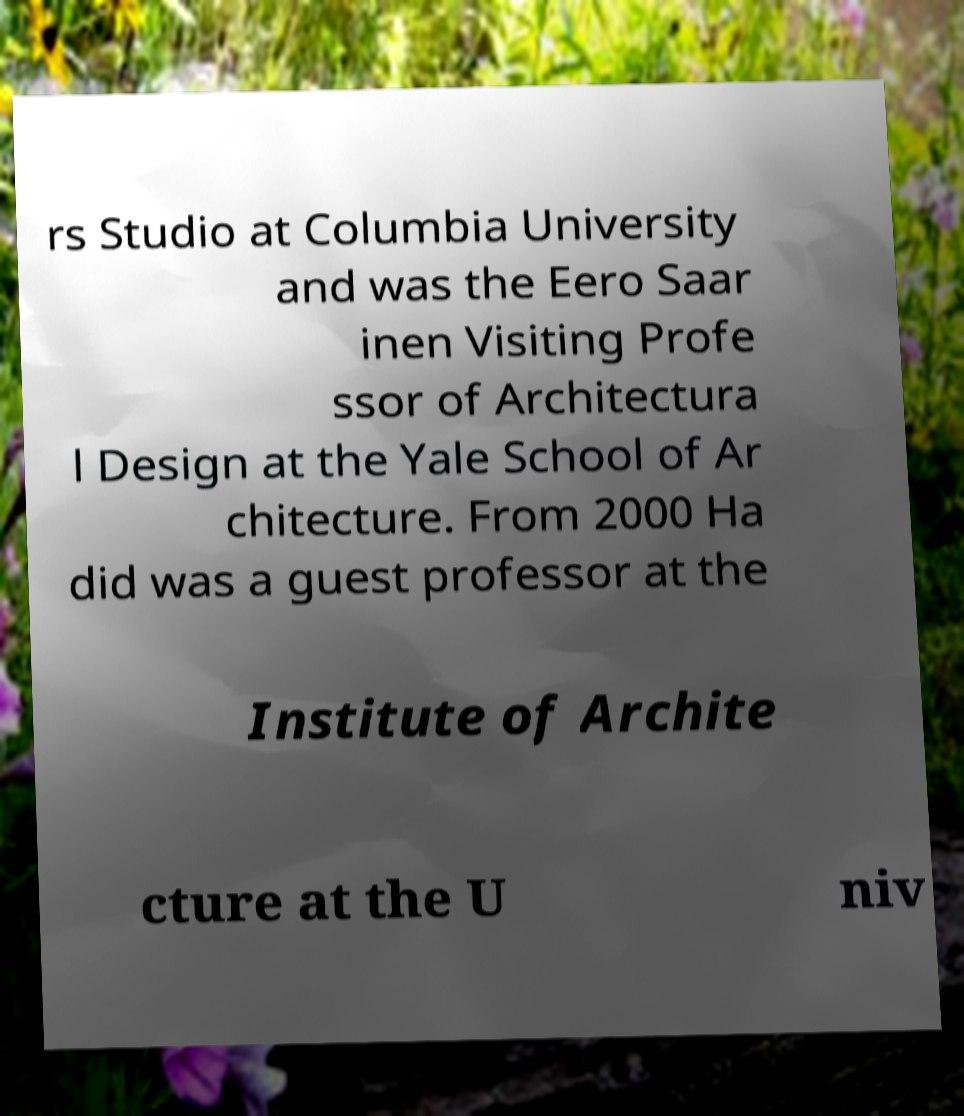Can you read and provide the text displayed in the image?This photo seems to have some interesting text. Can you extract and type it out for me? rs Studio at Columbia University and was the Eero Saar inen Visiting Profe ssor of Architectura l Design at the Yale School of Ar chitecture. From 2000 Ha did was a guest professor at the Institute of Archite cture at the U niv 